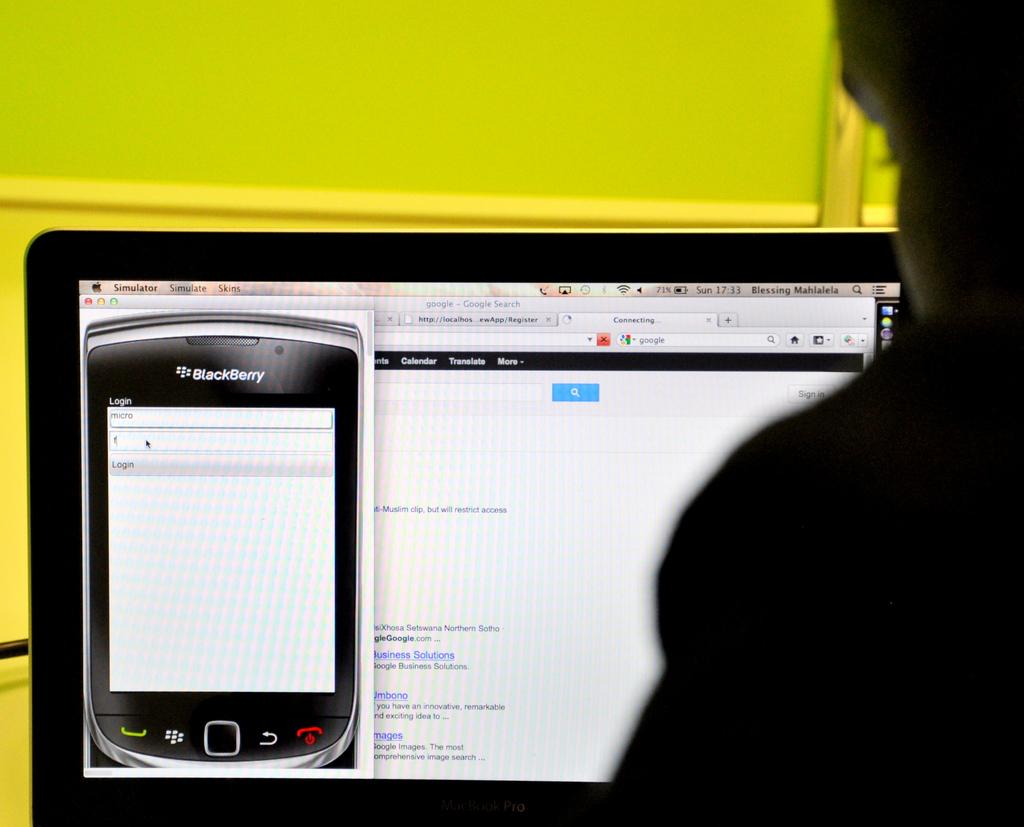What is the main focus of the image? The main focus of the image is a laptop screen. Can you describe anything else visible in the image? Yes, there appears to be a person on the right side of the image. What can be seen in the background of the image? There is a wall in the background of the image. What type of treatment is the queen receiving in the image? There is no queen or treatment present in the image; it features a laptop screen and a person. How does the acoustics of the room affect the sound quality in the image? The image does not provide any information about the acoustics of the room or the sound quality. 